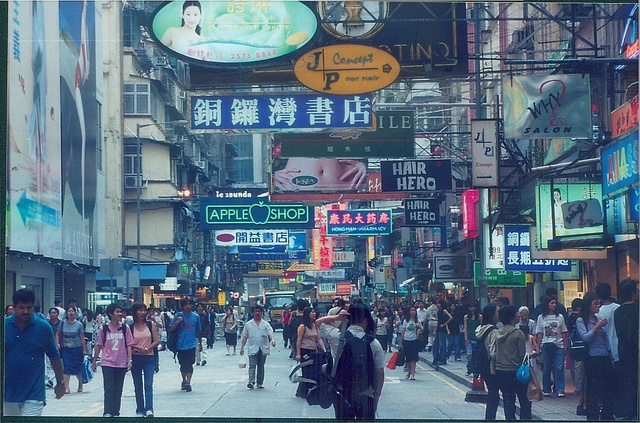Describe the objects in this image and their specific colors. I can see people in darkgray, navy, gray, and blue tones, people in darkgray, navy, blue, and gray tones, people in darkgray, navy, gray, purple, and darkblue tones, people in darkgray, navy, gray, and darkblue tones, and people in darkgray, navy, purple, darkblue, and gray tones in this image. 